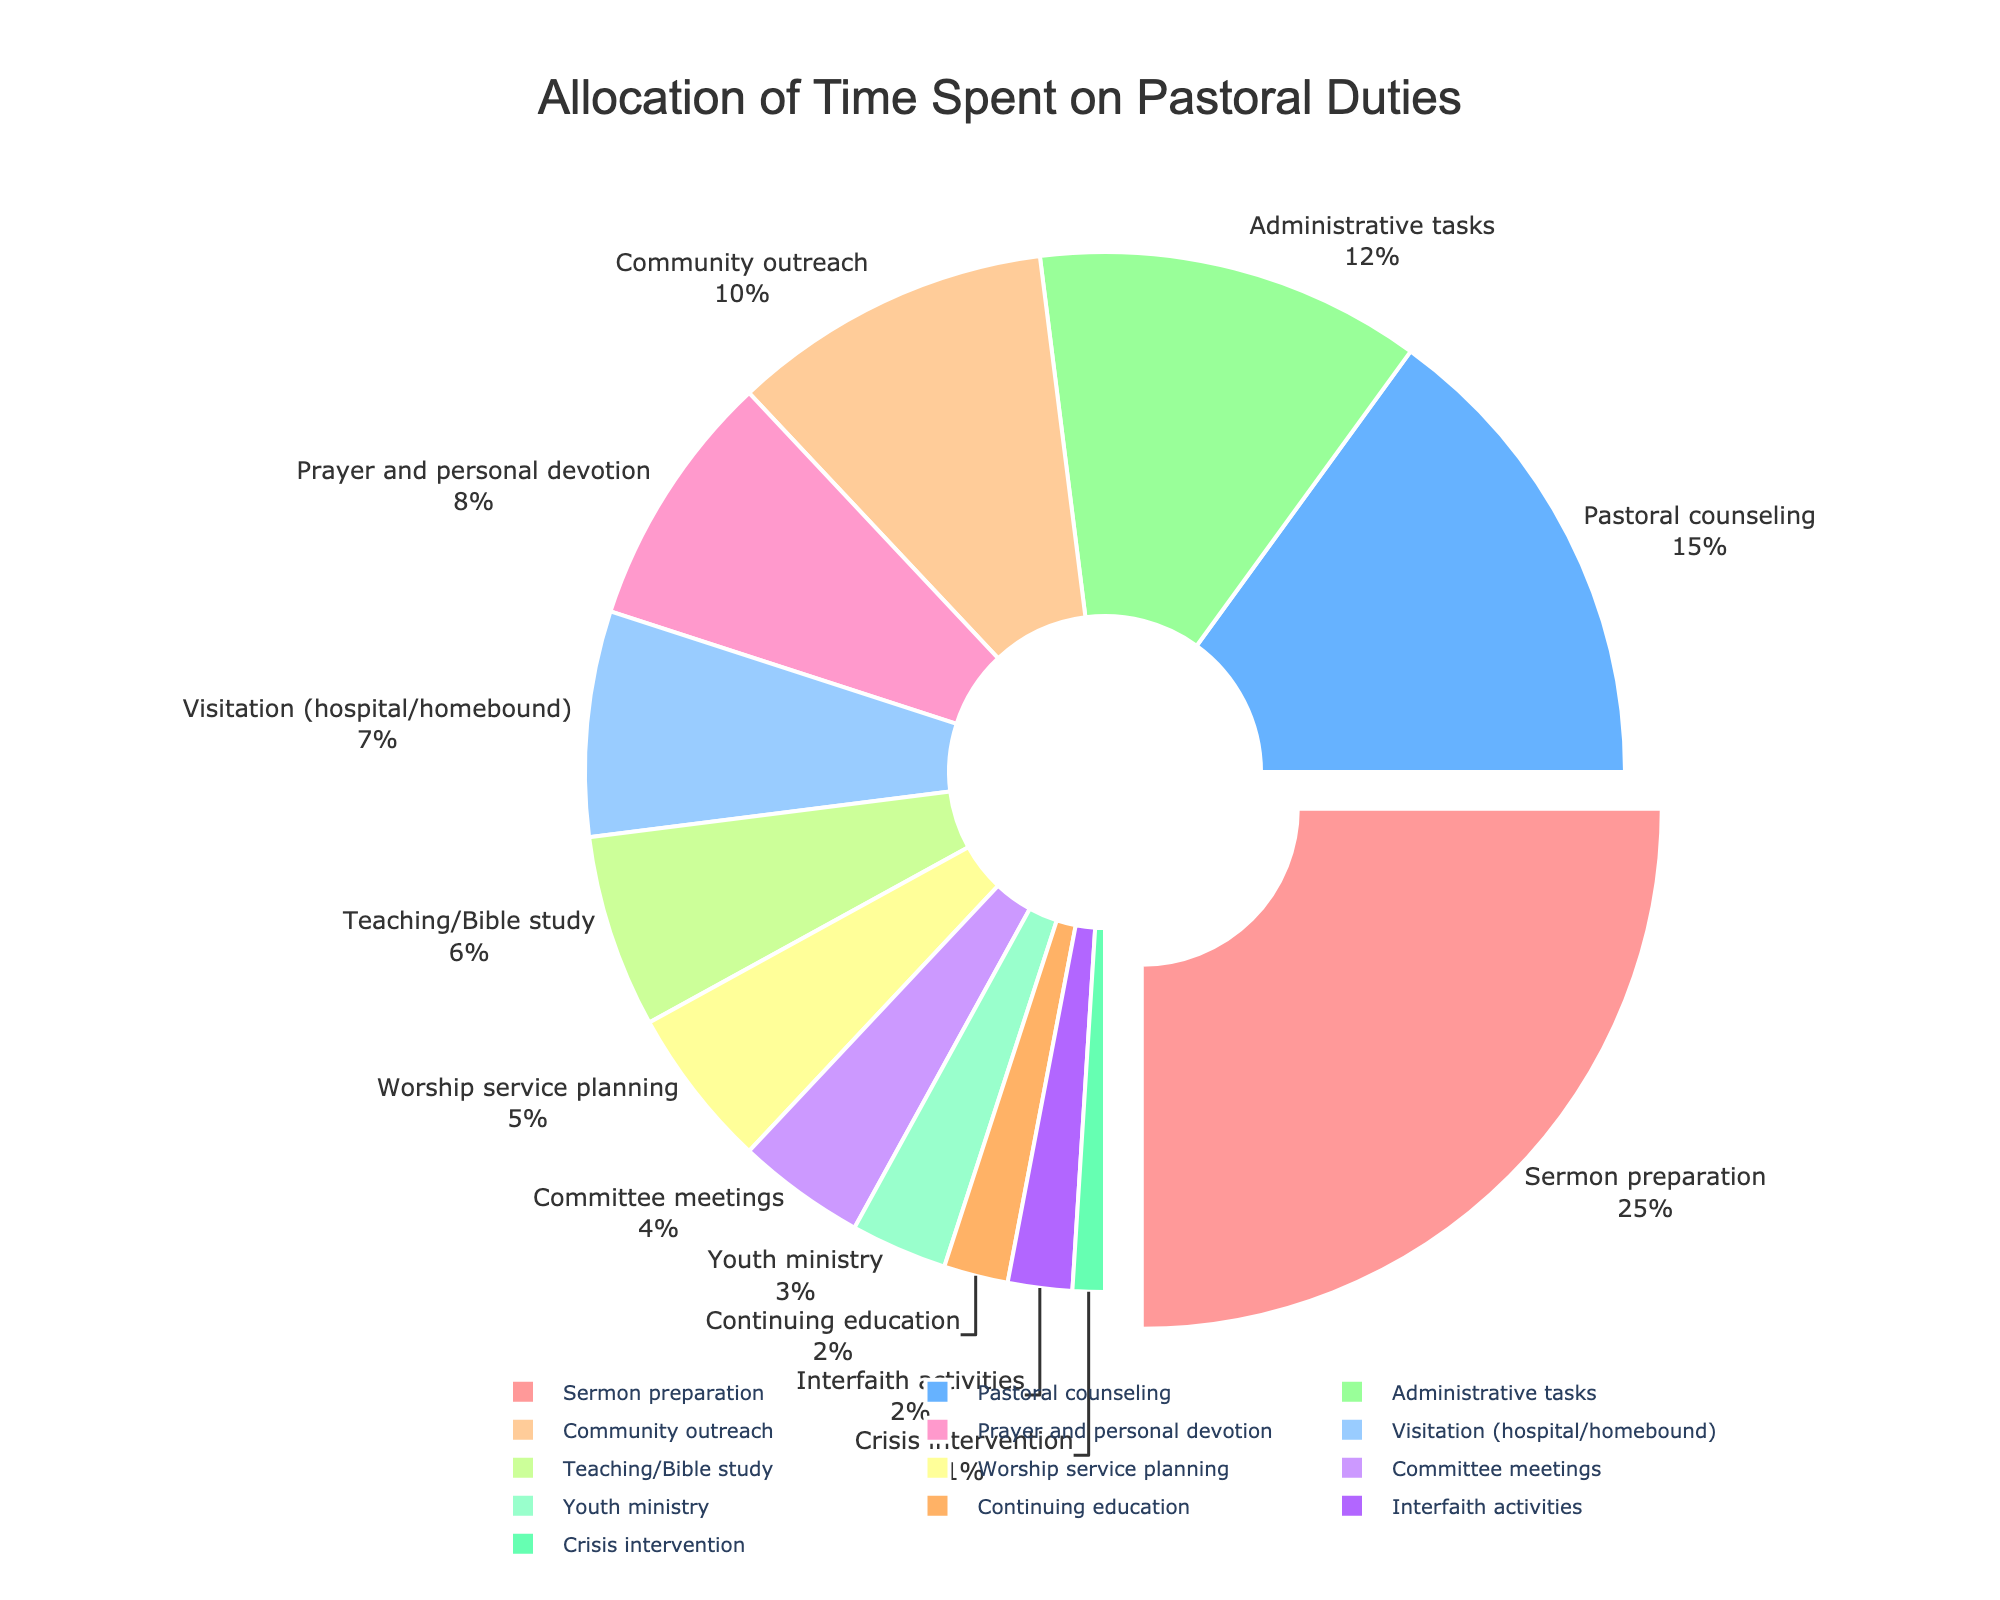What activity takes up the largest percentage of time according to the pie chart? The pie chart shows that "Sermon preparation" occupies the largest segment. By looking at the labeled percentages, "Sermon preparation" is identified as the largest.
Answer: Sermon preparation Which activity takes up more time: Pastoral counseling or Administrative tasks? By referring to the labeled percentages on the pie chart, "Pastoral counseling" is 15% and "Administrative tasks" is 12%. Comparing these percentages shows that "Pastoral counseling" takes up more time.
Answer: Pastoral counseling How much total time is spent on Community outreach, Teaching/Bible study, and Youth ministry? By looking at the pie chart, we see "Community outreach" is 10%, "Teaching/Bible study" is 6%, and "Youth ministry" is 3%. Summing these percentages, 10% + 6% + 3% results in 19%.
Answer: 19% What is the difference in time allocation between Visitation (hospital/homebound) and Prayer and personal devotion? The chart shows "Visitation (hospital/homebound)" at 7% and "Prayer and personal devotion" at 8%. The difference is calculated as 8% - 7%.
Answer: 1% Which activity occupies the smallest segment of the pie chart? By observing the pie chart, the smallest segment is labeled as "Crisis intervention" at 1%.
Answer: Crisis intervention Are there any activities that have the same percentage allocation? The pie chart shows that "Continuing education" and "Interfaith activities" each have a 2% allocation, indicating equal percentages.
Answer: Yes Which is more, the combined percentage of Worship service planning and Committee meetings, or Pastoral counseling? The chart shows that "Worship service planning" is 5%, "Committee meetings" is 4%, and "Pastoral counseling" is 15%. Calculating the combined percentage of "Worship service planning" and "Committee meetings" gives 5% + 4% = 9%. Comparing this to "Pastoral counseling" at 15% shows that "Pastoral counseling" has a larger percentage.
Answer: Pastoral counseling How much more time is allocated to Worship service planning compared to Youth ministry? The pie chart indicates "Worship service planning" is at 5% and "Youth ministry" at 3%. The difference is calculated as 5% - 3%.
Answer: 2% Which activities collectively take up more than half of the total time allocation? From the pie chart, add the largest percentages until exceeding 50%: "Sermon preparation" (25%), "Pastoral counseling" (15%), "Administrative tasks" (12%). Summing these gives 25% + 15% + 12% = 52%, which is more than half. So, the collective activities are "Sermon preparation," "Pastoral counseling," and "Administrative tasks."
Answer: Sermon preparation, Pastoral counseling, Administrative tasks 